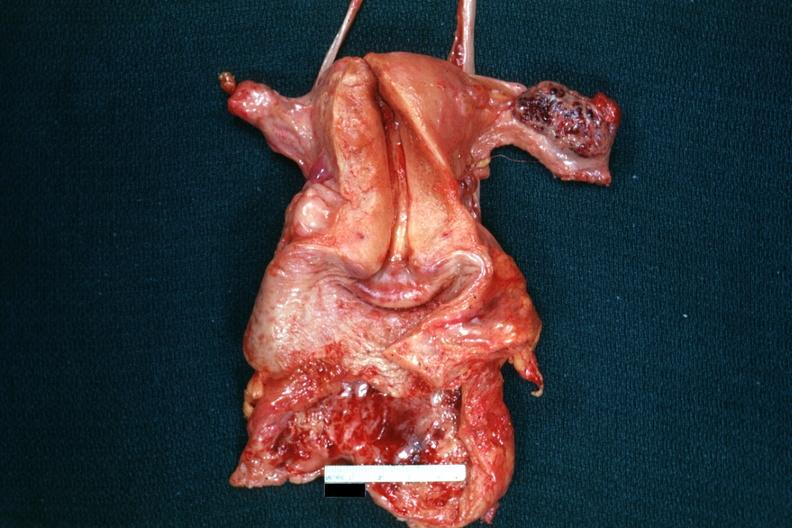what is present?
Answer the question using a single word or phrase. Female reproductive 